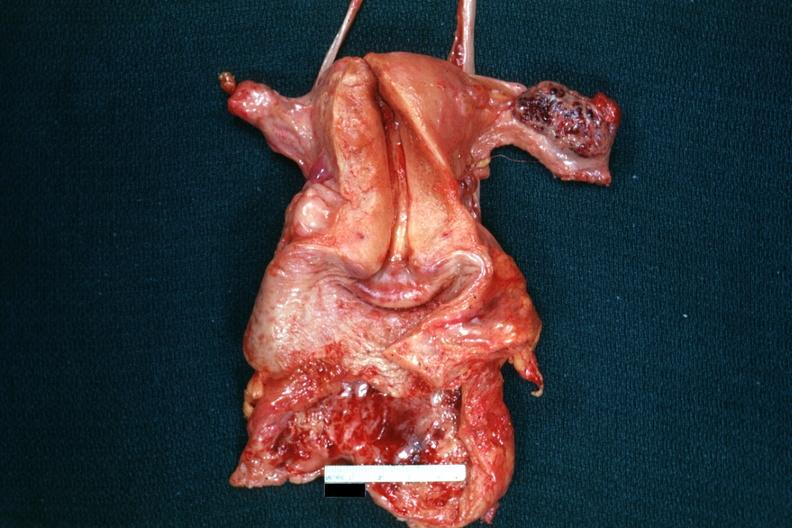what is present?
Answer the question using a single word or phrase. Female reproductive 